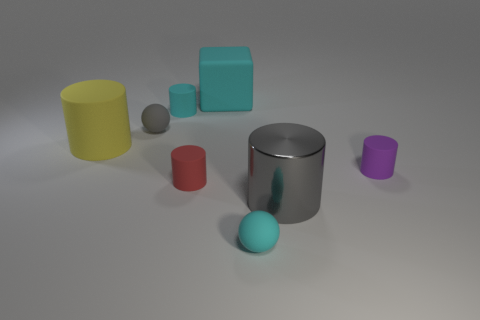Is there anything else that has the same material as the gray cylinder?
Offer a terse response. No. There is a small cylinder that is the same color as the block; what is it made of?
Your answer should be compact. Rubber. Is the color of the big rubber block the same as the big metallic cylinder?
Ensure brevity in your answer.  No. There is a big rubber thing to the left of the large matte thing that is right of the tiny gray ball; how many red things are behind it?
Your answer should be compact. 0. The purple object that is made of the same material as the big yellow cylinder is what shape?
Keep it short and to the point. Cylinder. What is the material of the small cylinder behind the small matte sphere that is behind the rubber thing in front of the red object?
Give a very brief answer. Rubber. How many objects are either rubber spheres right of the large cyan rubber thing or gray cylinders?
Your answer should be very brief. 2. What number of other objects are the same shape as the small red matte object?
Offer a very short reply. 4. Is the number of tiny cyan objects in front of the red rubber cylinder greater than the number of tiny purple shiny cylinders?
Your response must be concise. Yes. The cyan object that is the same shape as the tiny gray thing is what size?
Your answer should be compact. Small. 